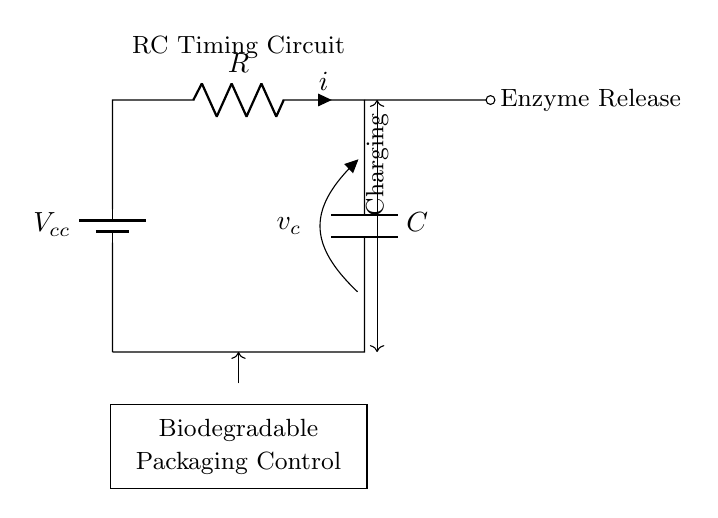What is the component that stores charge? The capacitor in the circuit is the component responsible for storing electrical charge. In the diagram, it is labeled as "C."
Answer: Capacitor What is the purpose of the resistor in this circuit? The resistor limits the current flowing through the circuit, influencing the charging rate of the capacitor. It helps define the time constant in an RC timing circuit.
Answer: Limit current What is the function indicated by the output from the circuit? The output labeled "Enzyme Release" indicates the circuit's function of releasing enzymes at a controlled rate, making it integral in the biodegradable packaging application.
Answer: Enzyme Release What is the voltage represented by \( V_{cc} \)? \( V_{cc} \) indicates the supply voltage of the circuit, providing the necessary electrical energy for the operation of the components. In general, it represents the positive voltage source connected to the circuit.
Answer: Supply voltage What is the time constant of the RC circuit based on the components? The time constant \( \tau \) is calculated using the formula \( \tau = R \times C \), where \( R \) is the resistance and \( C \) is the capacitance. The specific values would depend on the components used, which are not detailed in the diagram.
Answer: R times C How does the charging period influence enzyme release? The charging period, represented by the current flow and the behavior of the capacitor, directly influences the timing and amount of enzyme released. The longer the charging period, the more controlled the release can be, affecting biodegradation rates.
Answer: Influences timing What type of circuit is this? This is an RC timing circuit, which is specifically designed to create a timing delay by controlling the charge and discharge of the capacitor through the resistor, suitable for applications such as enzyme release in biodegradable materials.
Answer: RC timing circuit 